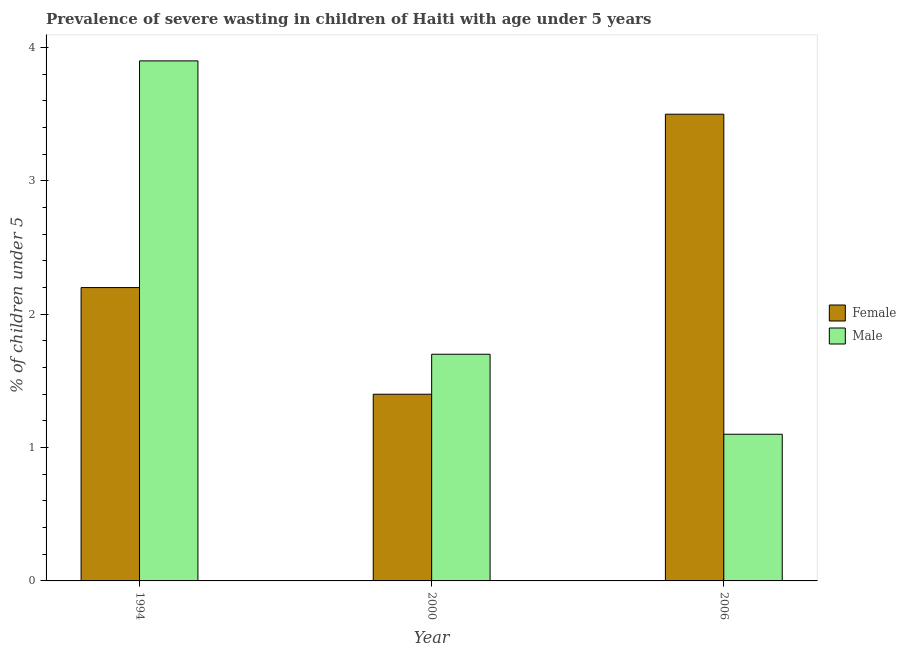How many different coloured bars are there?
Offer a terse response. 2. How many groups of bars are there?
Give a very brief answer. 3. Are the number of bars on each tick of the X-axis equal?
Provide a succinct answer. Yes. How many bars are there on the 1st tick from the left?
Your response must be concise. 2. How many bars are there on the 1st tick from the right?
Your answer should be very brief. 2. What is the label of the 1st group of bars from the left?
Provide a succinct answer. 1994. What is the percentage of undernourished male children in 2000?
Your response must be concise. 1.7. Across all years, what is the minimum percentage of undernourished female children?
Your answer should be compact. 1.4. In which year was the percentage of undernourished male children maximum?
Your answer should be very brief. 1994. What is the total percentage of undernourished female children in the graph?
Offer a terse response. 7.1. What is the difference between the percentage of undernourished female children in 1994 and that in 2000?
Provide a succinct answer. 0.8. What is the difference between the percentage of undernourished female children in 1994 and the percentage of undernourished male children in 2006?
Your response must be concise. -1.3. What is the average percentage of undernourished female children per year?
Offer a terse response. 2.37. What is the ratio of the percentage of undernourished male children in 1994 to that in 2006?
Your response must be concise. 3.55. What is the difference between the highest and the second highest percentage of undernourished female children?
Provide a short and direct response. 1.3. What is the difference between the highest and the lowest percentage of undernourished female children?
Provide a succinct answer. 2.1. In how many years, is the percentage of undernourished female children greater than the average percentage of undernourished female children taken over all years?
Ensure brevity in your answer.  1. Is the sum of the percentage of undernourished male children in 1994 and 2006 greater than the maximum percentage of undernourished female children across all years?
Your response must be concise. Yes. What does the 2nd bar from the left in 1994 represents?
Ensure brevity in your answer.  Male. What does the 2nd bar from the right in 1994 represents?
Offer a terse response. Female. How many bars are there?
Ensure brevity in your answer.  6. Are all the bars in the graph horizontal?
Your answer should be very brief. No. How many years are there in the graph?
Ensure brevity in your answer.  3. What is the difference between two consecutive major ticks on the Y-axis?
Give a very brief answer. 1. Are the values on the major ticks of Y-axis written in scientific E-notation?
Ensure brevity in your answer.  No. Does the graph contain any zero values?
Provide a succinct answer. No. Does the graph contain grids?
Your response must be concise. No. How many legend labels are there?
Your answer should be very brief. 2. What is the title of the graph?
Offer a terse response. Prevalence of severe wasting in children of Haiti with age under 5 years. What is the label or title of the Y-axis?
Keep it short and to the point.  % of children under 5. What is the  % of children under 5 of Female in 1994?
Your answer should be very brief. 2.2. What is the  % of children under 5 of Male in 1994?
Ensure brevity in your answer.  3.9. What is the  % of children under 5 of Female in 2000?
Your response must be concise. 1.4. What is the  % of children under 5 of Male in 2000?
Your answer should be compact. 1.7. What is the  % of children under 5 in Male in 2006?
Provide a short and direct response. 1.1. Across all years, what is the maximum  % of children under 5 of Male?
Keep it short and to the point. 3.9. Across all years, what is the minimum  % of children under 5 of Female?
Make the answer very short. 1.4. Across all years, what is the minimum  % of children under 5 in Male?
Ensure brevity in your answer.  1.1. What is the difference between the  % of children under 5 of Male in 1994 and that in 2000?
Ensure brevity in your answer.  2.2. What is the difference between the  % of children under 5 in Male in 2000 and that in 2006?
Provide a short and direct response. 0.6. What is the difference between the  % of children under 5 of Female in 2000 and the  % of children under 5 of Male in 2006?
Offer a very short reply. 0.3. What is the average  % of children under 5 in Female per year?
Your response must be concise. 2.37. What is the average  % of children under 5 in Male per year?
Your answer should be very brief. 2.23. In the year 2000, what is the difference between the  % of children under 5 of Female and  % of children under 5 of Male?
Provide a short and direct response. -0.3. In the year 2006, what is the difference between the  % of children under 5 in Female and  % of children under 5 in Male?
Ensure brevity in your answer.  2.4. What is the ratio of the  % of children under 5 of Female in 1994 to that in 2000?
Ensure brevity in your answer.  1.57. What is the ratio of the  % of children under 5 of Male in 1994 to that in 2000?
Your answer should be very brief. 2.29. What is the ratio of the  % of children under 5 in Female in 1994 to that in 2006?
Provide a succinct answer. 0.63. What is the ratio of the  % of children under 5 of Male in 1994 to that in 2006?
Your answer should be compact. 3.55. What is the ratio of the  % of children under 5 in Female in 2000 to that in 2006?
Give a very brief answer. 0.4. What is the ratio of the  % of children under 5 of Male in 2000 to that in 2006?
Keep it short and to the point. 1.55. What is the difference between the highest and the lowest  % of children under 5 of Female?
Offer a very short reply. 2.1. What is the difference between the highest and the lowest  % of children under 5 of Male?
Make the answer very short. 2.8. 